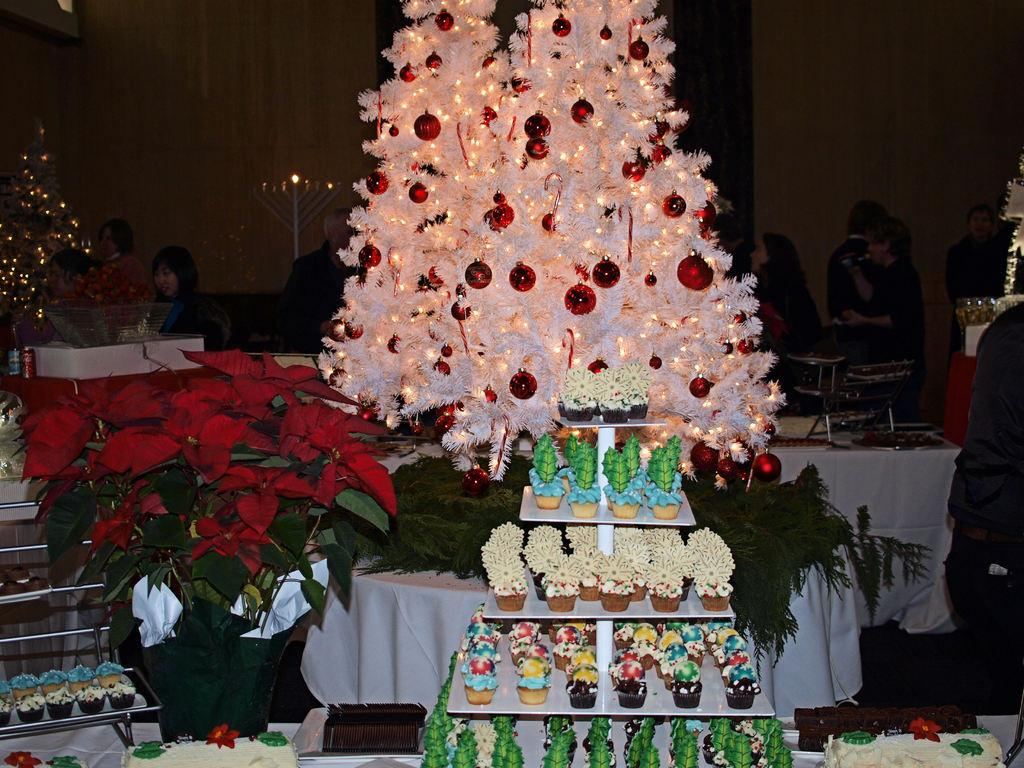What is on the tray that is visible in the image? There is a tray with cupcakes in the image. What theme or occasion is suggested by the image? The image is related to Christmas. What type of container is present in the image? There is a flower pot in the image. What piece of furniture is visible in the image? There is a table in the image. How many people are present at the table in the image? People are surrounded at the table. What type of collar can be seen on the boy in the image? There is no boy present in the image, so there is no collar to be seen. 